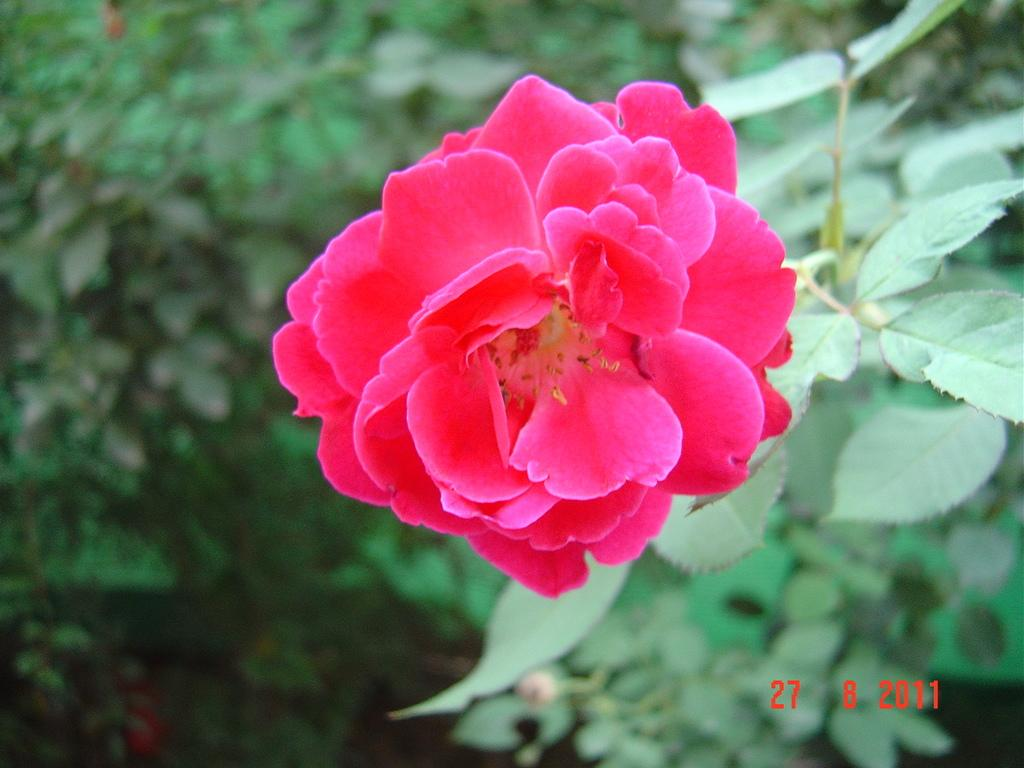What type of living organisms can be seen in the image? Plants and a flower are visible in the image. What color is the flower in the image? The flower in the image is pink. How many potatoes are present in the image? There are no potatoes visible in the image. What mode of transport is used to carry the flower in the image? The image does not depict any mode of transport, as the flower is stationary. 